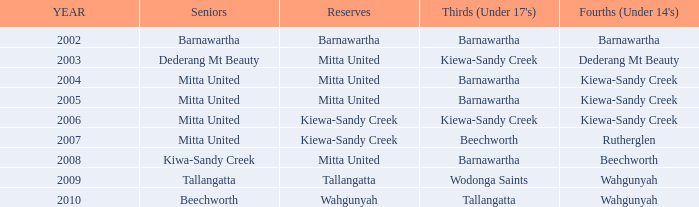Which senior members joined before 2006 and are part of the kiewa-sandy creek under 14's (fourths) team? Mitta United, Mitta United. 